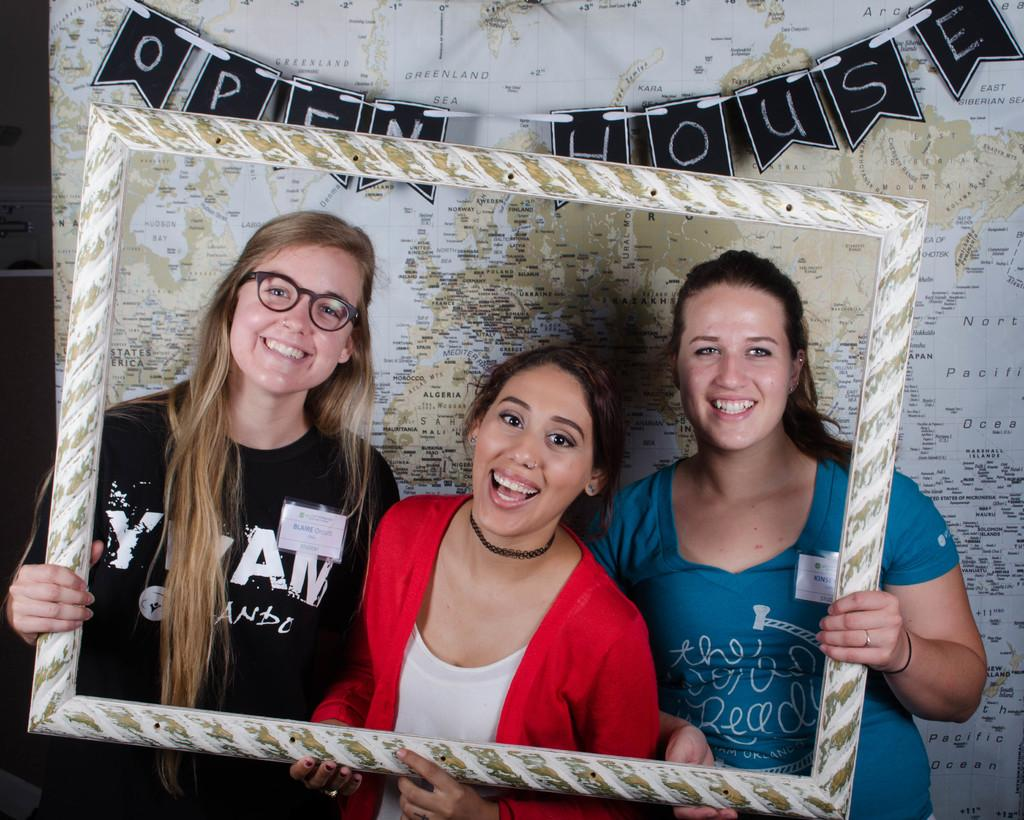How many women are in the image? There are three women at the bottom of the image. What are the women wearing? The women are wearing different color dresses. What are the women holding? The women are holding a frame. What is the facial expression of the women? The women are smiling. What position are the women in? The women are standing. What can be seen in the background of the image? There is a map in the background of the image. What type of laborer is working in the background of the image? There is no laborer present in the image; it only features three women and a map in the background. What punishment is being administered to the women in the image? There is no punishment being administered to the women in the image; they are smiling and holding a frame. 